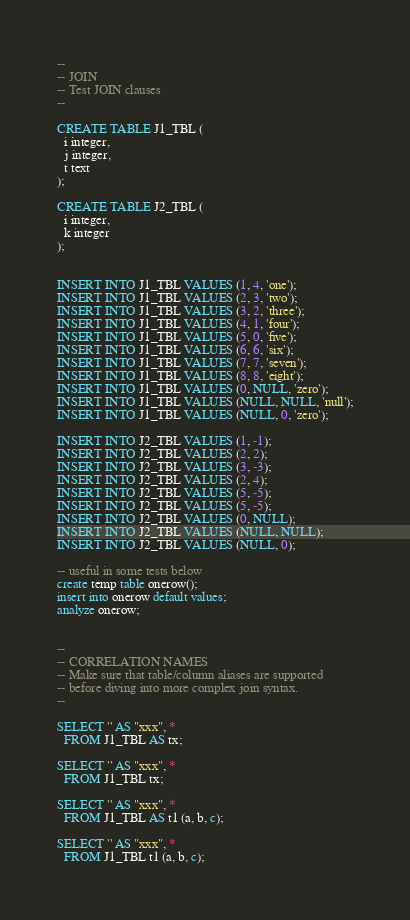<code> <loc_0><loc_0><loc_500><loc_500><_SQL_>--
-- JOIN
-- Test JOIN clauses
--

CREATE TABLE J1_TBL (
  i integer,
  j integer,
  t text
);

CREATE TABLE J2_TBL (
  i integer,
  k integer
);


INSERT INTO J1_TBL VALUES (1, 4, 'one');
INSERT INTO J1_TBL VALUES (2, 3, 'two');
INSERT INTO J1_TBL VALUES (3, 2, 'three');
INSERT INTO J1_TBL VALUES (4, 1, 'four');
INSERT INTO J1_TBL VALUES (5, 0, 'five');
INSERT INTO J1_TBL VALUES (6, 6, 'six');
INSERT INTO J1_TBL VALUES (7, 7, 'seven');
INSERT INTO J1_TBL VALUES (8, 8, 'eight');
INSERT INTO J1_TBL VALUES (0, NULL, 'zero');
INSERT INTO J1_TBL VALUES (NULL, NULL, 'null');
INSERT INTO J1_TBL VALUES (NULL, 0, 'zero');

INSERT INTO J2_TBL VALUES (1, -1);
INSERT INTO J2_TBL VALUES (2, 2);
INSERT INTO J2_TBL VALUES (3, -3);
INSERT INTO J2_TBL VALUES (2, 4);
INSERT INTO J2_TBL VALUES (5, -5);
INSERT INTO J2_TBL VALUES (5, -5);
INSERT INTO J2_TBL VALUES (0, NULL);
INSERT INTO J2_TBL VALUES (NULL, NULL);
INSERT INTO J2_TBL VALUES (NULL, 0);

-- useful in some tests below
create temp table onerow();
insert into onerow default values;
analyze onerow;


--
-- CORRELATION NAMES
-- Make sure that table/column aliases are supported
-- before diving into more complex join syntax.
--

SELECT '' AS "xxx", *
  FROM J1_TBL AS tx;

SELECT '' AS "xxx", *
  FROM J1_TBL tx;

SELECT '' AS "xxx", *
  FROM J1_TBL AS t1 (a, b, c);

SELECT '' AS "xxx", *
  FROM J1_TBL t1 (a, b, c);
</code> 